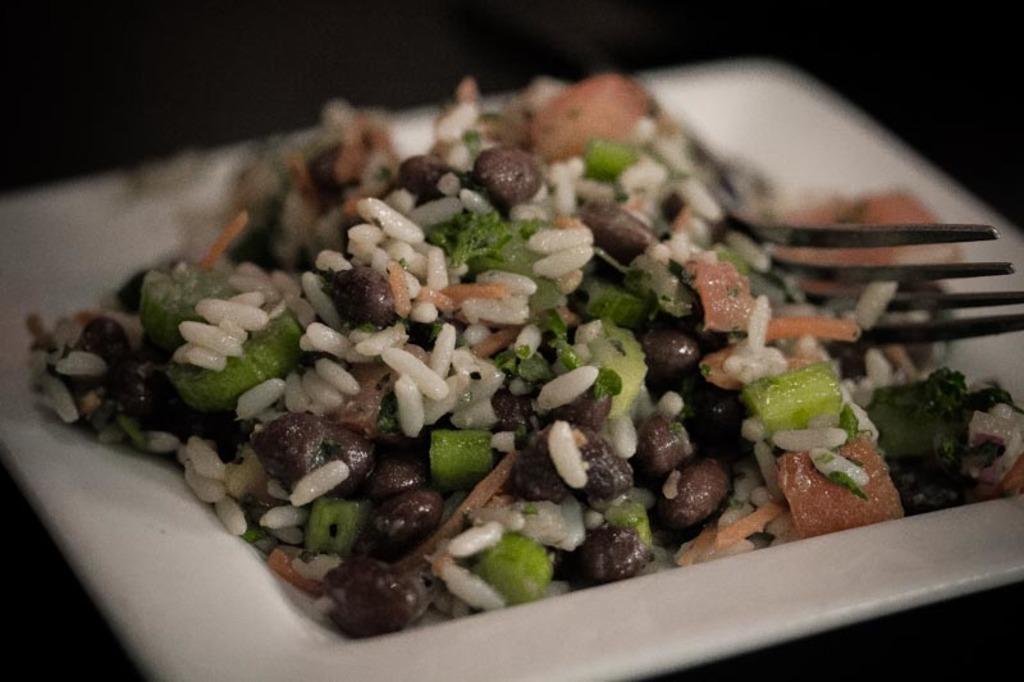Describe this image in one or two sentences. In this picture we can see a plate, fork, and food. 